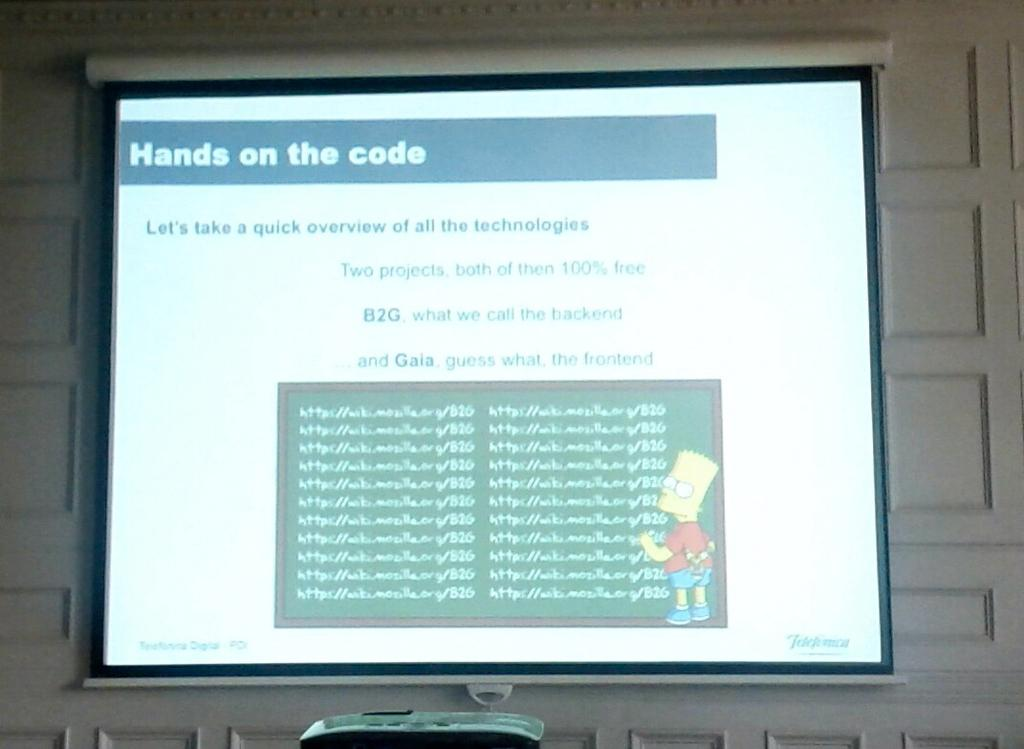Provide a one-sentence caption for the provided image. Bart Simpson is teaching coding in a slideshow. 